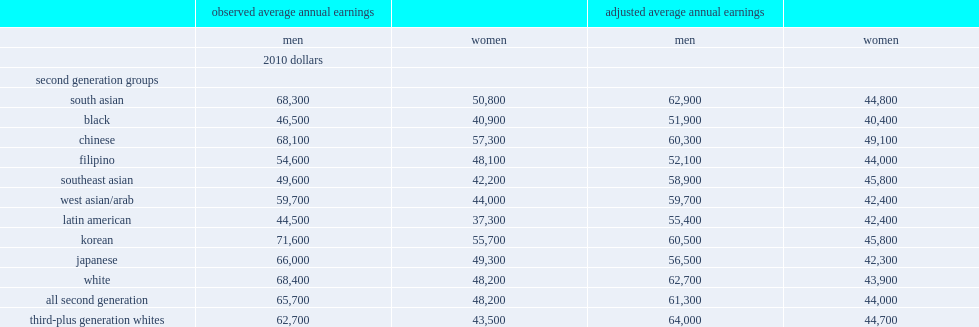List all the second generation minority groups that earned more than third-plus generation white men by ovserved. South asian chinese korean japanese. List all the second generation minority groups that earned less than third-plus generation white men by ovserved. Black filipino southeast asian west asian/arab latin american. Which two second generation gtoups men had the lowest earnings by ovserved? Black latin american. How much more did chinese women earn than white women of the third-plus generation by ovserved? 0.317241. How much more did koreanwomen earn than white women of the third-plus generation by ovserved? 0.28046. What is the proportion second generation chinese women have earnings higher than third-plus generation white women after asjustment? 0.098434. 